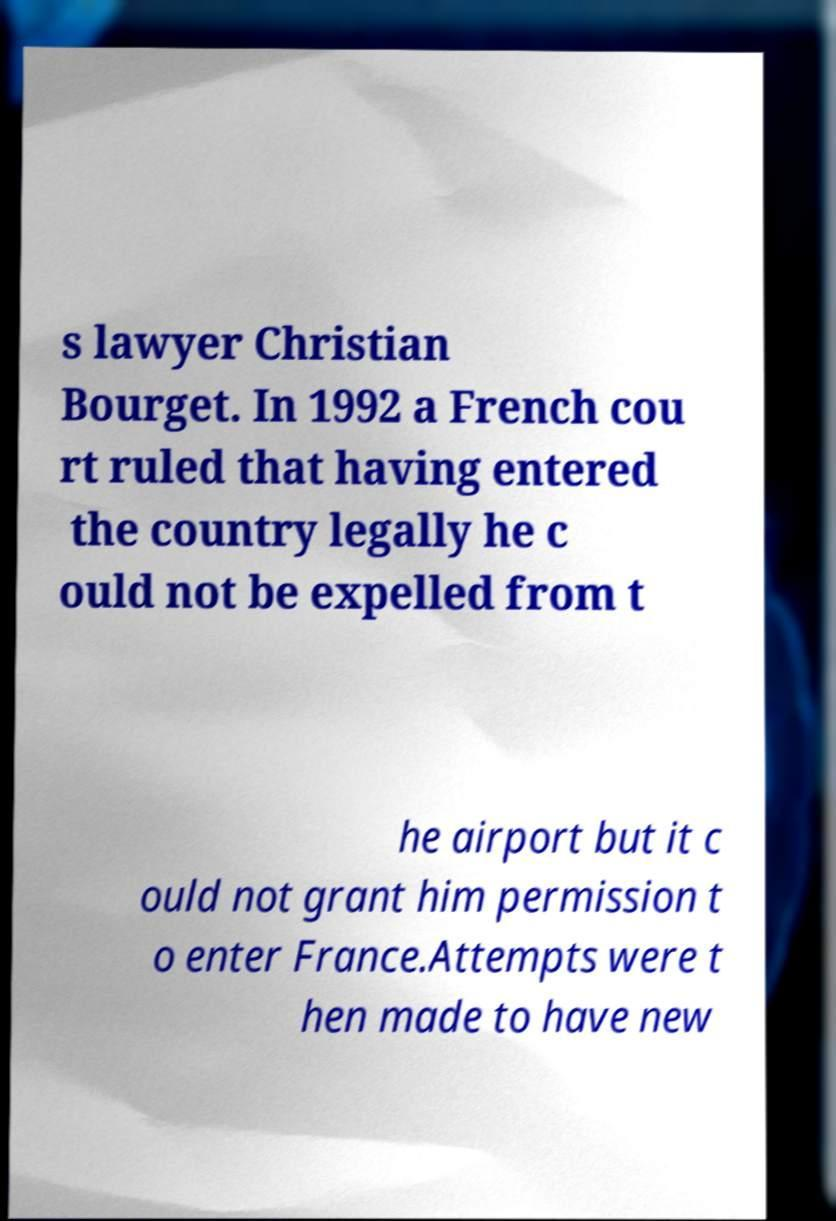For documentation purposes, I need the text within this image transcribed. Could you provide that? s lawyer Christian Bourget. In 1992 a French cou rt ruled that having entered the country legally he c ould not be expelled from t he airport but it c ould not grant him permission t o enter France.Attempts were t hen made to have new 